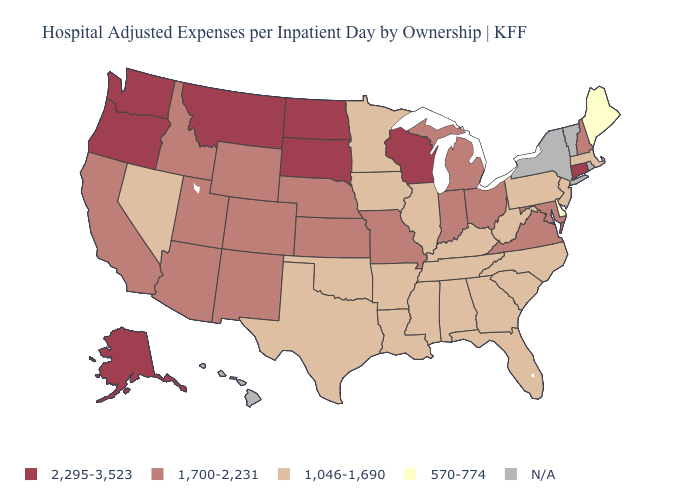Among the states that border Illinois , does Indiana have the lowest value?
Short answer required. No. Among the states that border Wyoming , does South Dakota have the highest value?
Concise answer only. Yes. Among the states that border New Hampshire , which have the lowest value?
Keep it brief. Maine. Name the states that have a value in the range 1,046-1,690?
Short answer required. Alabama, Arkansas, Florida, Georgia, Illinois, Iowa, Kentucky, Louisiana, Massachusetts, Minnesota, Mississippi, Nevada, New Jersey, North Carolina, Oklahoma, Pennsylvania, South Carolina, Tennessee, Texas, West Virginia. What is the value of West Virginia?
Concise answer only. 1,046-1,690. What is the value of Kansas?
Keep it brief. 1,700-2,231. Name the states that have a value in the range N/A?
Write a very short answer. Hawaii, New York, Rhode Island, Vermont. Name the states that have a value in the range 2,295-3,523?
Concise answer only. Alaska, Connecticut, Montana, North Dakota, Oregon, South Dakota, Washington, Wisconsin. Which states have the highest value in the USA?
Short answer required. Alaska, Connecticut, Montana, North Dakota, Oregon, South Dakota, Washington, Wisconsin. Name the states that have a value in the range N/A?
Keep it brief. Hawaii, New York, Rhode Island, Vermont. Does the first symbol in the legend represent the smallest category?
Write a very short answer. No. Is the legend a continuous bar?
Short answer required. No. Does Georgia have the highest value in the South?
Give a very brief answer. No. What is the value of Arkansas?
Be succinct. 1,046-1,690. 